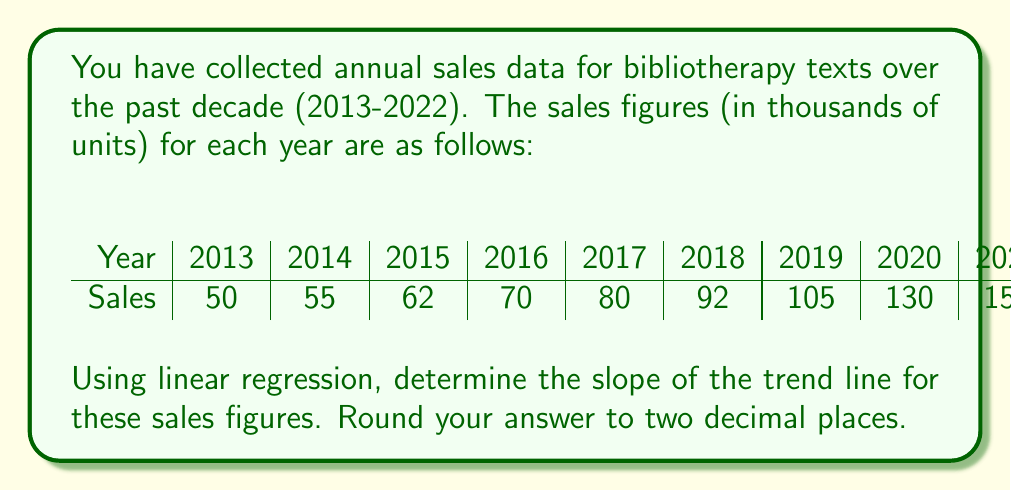Could you help me with this problem? To find the slope of the trend line using linear regression, we'll use the formula:

$$ m = \frac{n\sum xy - \sum x \sum y}{n\sum x^2 - (\sum x)^2} $$

Where:
$m$ is the slope
$n$ is the number of data points
$x$ represents the years (coded as 1, 2, 3, ..., 10)
$y$ represents the sales figures

Let's calculate the necessary components:

1. $n = 10$ (10 years of data)
2. $\sum x = 1 + 2 + 3 + ... + 10 = 55$
3. $\sum y = 50 + 55 + 62 + ... + 175 = 969$
4. $\sum xy = (1 \times 50) + (2 \times 55) + ... + (10 \times 175) = 7,988$
5. $\sum x^2 = 1^2 + 2^2 + ... + 10^2 = 385$

Now, let's substitute these values into the formula:

$$ m = \frac{10(7,988) - 55(969)}{10(385) - 55^2} $$

$$ m = \frac{79,880 - 53,295}{3,850 - 3,025} $$

$$ m = \frac{26,585}{825} $$

$$ m = 32.22424242... $$

Rounding to two decimal places:

$$ m \approx 32.22 $$
Answer: 32.22 